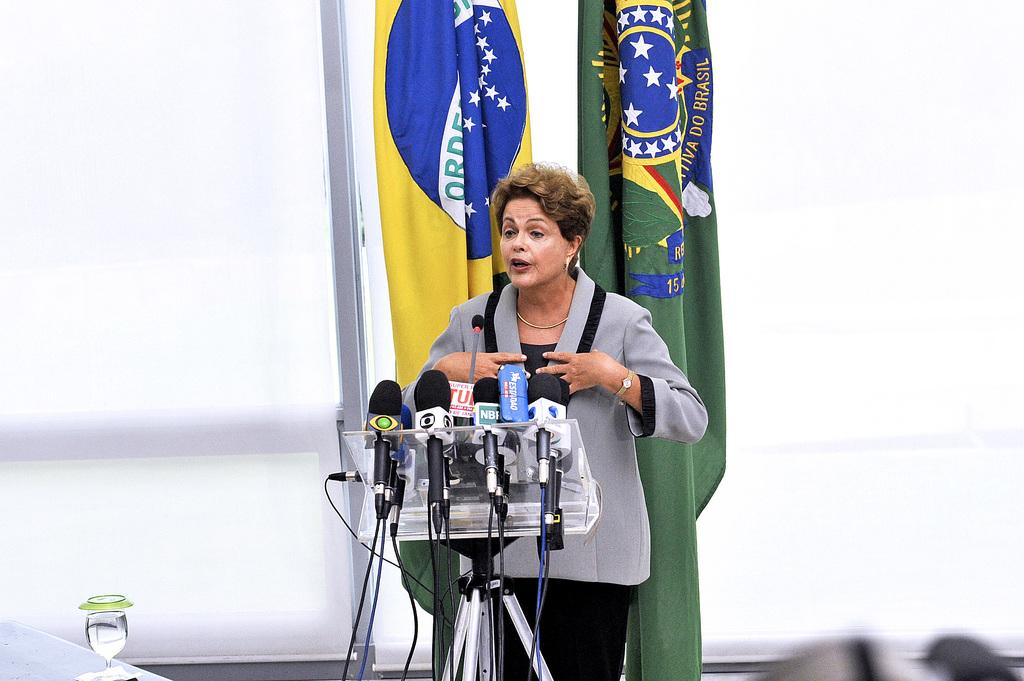Who is the main subject in the image? There is a woman in the image. What is the woman doing in the image? The woman is standing in front of microphones. What can be seen in the background of the image? There are flags in the background of the image. Can you identify any other objects in the image? Yes, there is a glass visible in the image. What type of push is the woman giving to the microphones in the image? There is no indication of the woman pushing the microphones in the image; she is standing in front of them, which suggests she may be using them for a performance or presentation. 